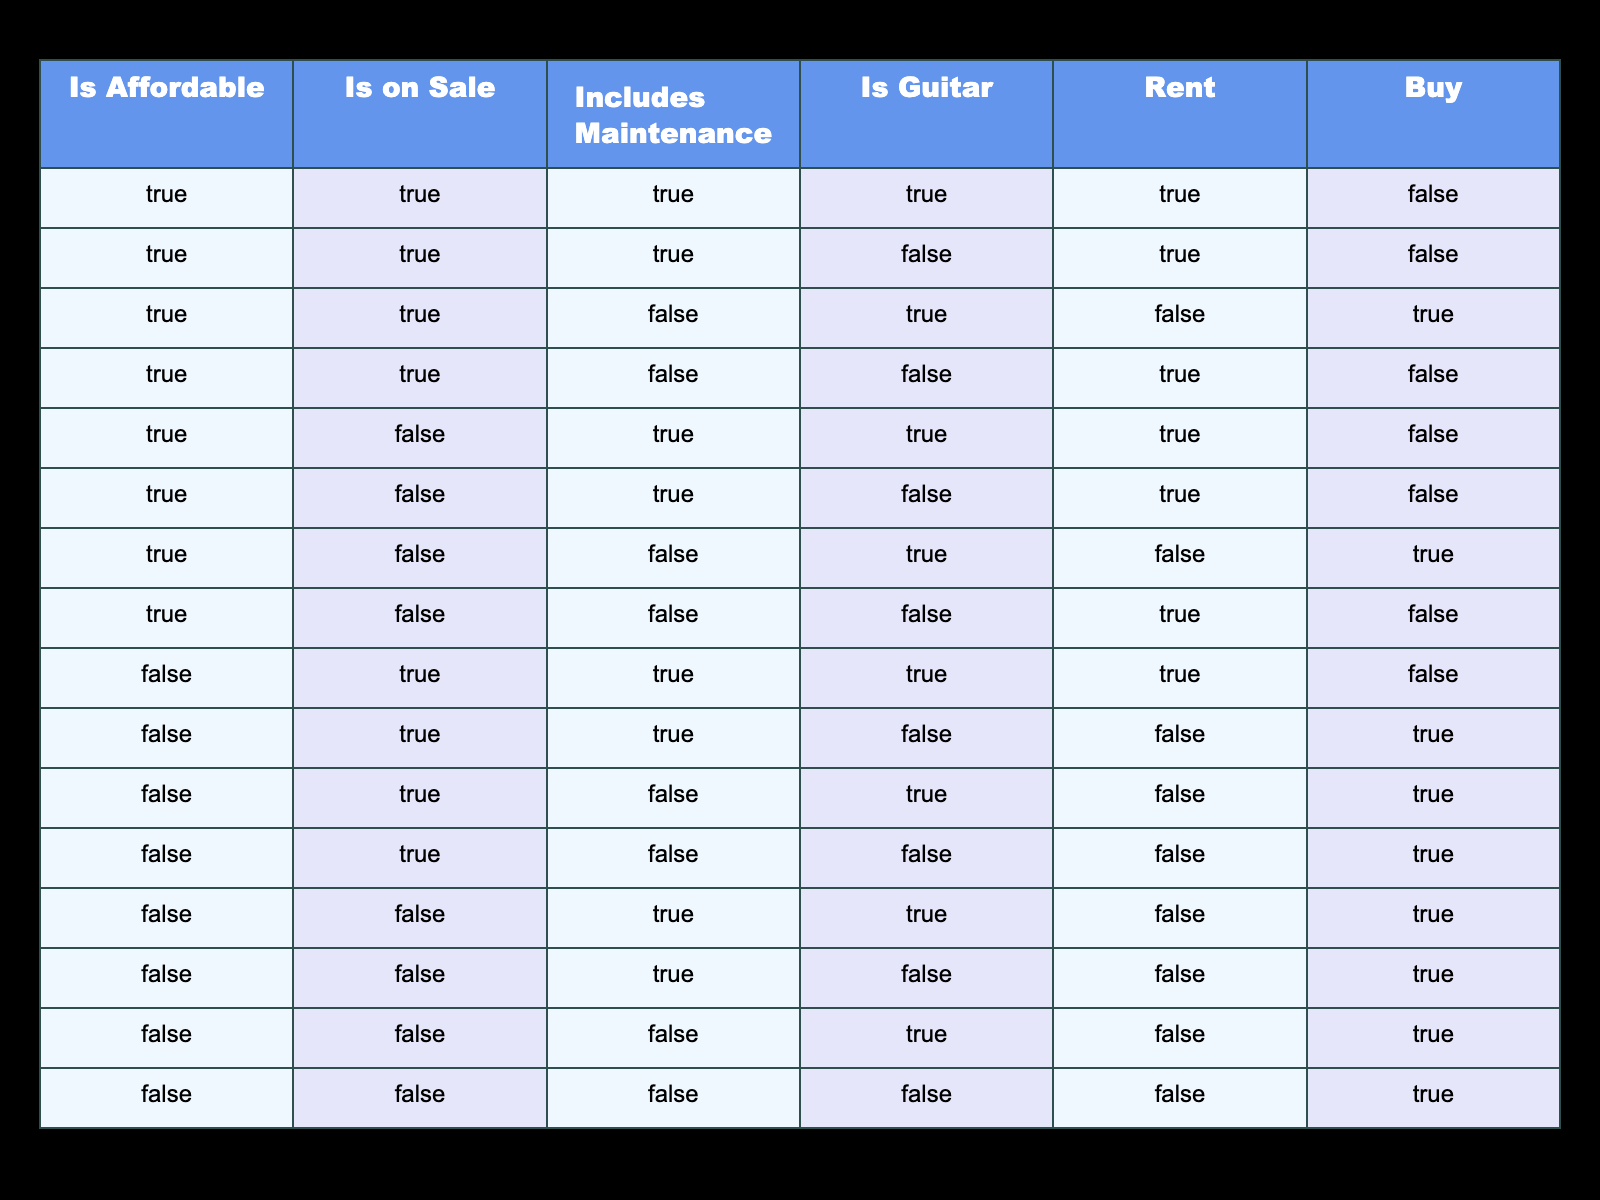Is it affordable to rent a guitar that includes maintenance? Looking at the table, we see that the row corresponding to renting a guitar with maintenance is true. Therefore, it is affordable to rent such an instrument.
Answer: Yes How many rental options are there for guitars that are on sale? By examining the rows where the "Is on Sale" is true and counting those where "Rent" is also true, we find three rental options that fulfill both conditions.
Answer: 3 Are there any purchase options for guitars that are affordable and include maintenance? In the table, we find that there are no purchase options where both "Is Affordable" is true and "Includes Maintenance" is true since they all indicate rent only.
Answer: No What percentage of all options are rental guitars? Out of the total 16 options provided in the table, 8 are rental options. The percentage is calculated as (8/16) * 100 = 50%.
Answer: 50% Is there a purchase option for an affordable guitar that is not on sale? Checking the rows where "Is Affordable" is true and "Is on Sale" is false, we see that there is indeed a purchase option available.
Answer: Yes How many total options are there that include maintenance? After reviewing the table, we see that there are 6 options that include maintenance since we count the respective rows with "Includes Maintenance" marked as true.
Answer: 6 Are all guitars that are on sale available for rent? By examining the table, we discover that only some guitars that are on sale are available for rent. Therefore, not all on-sale guitars are available for rent.
Answer: No What is the ratio of rental options to purchase options for guitars that are affordable? There are 5 rental options and 1 purchase option for affordable guitars, leading to a ratio of 5:1 when only counting the respective guitar types.
Answer: 5:1 